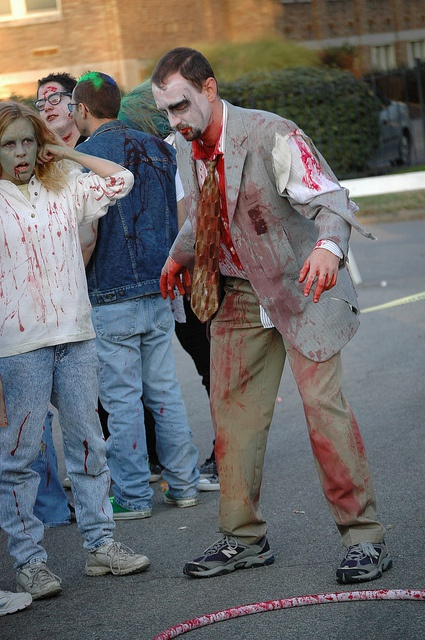Describe the objects in this image and their specific colors. I can see people in tan, gray, darkgray, and maroon tones, people in tan, gray, lightgray, and darkgray tones, people in tan, navy, gray, and black tones, tie in tan, maroon, black, and gray tones, and car in tan, black, and purple tones in this image. 